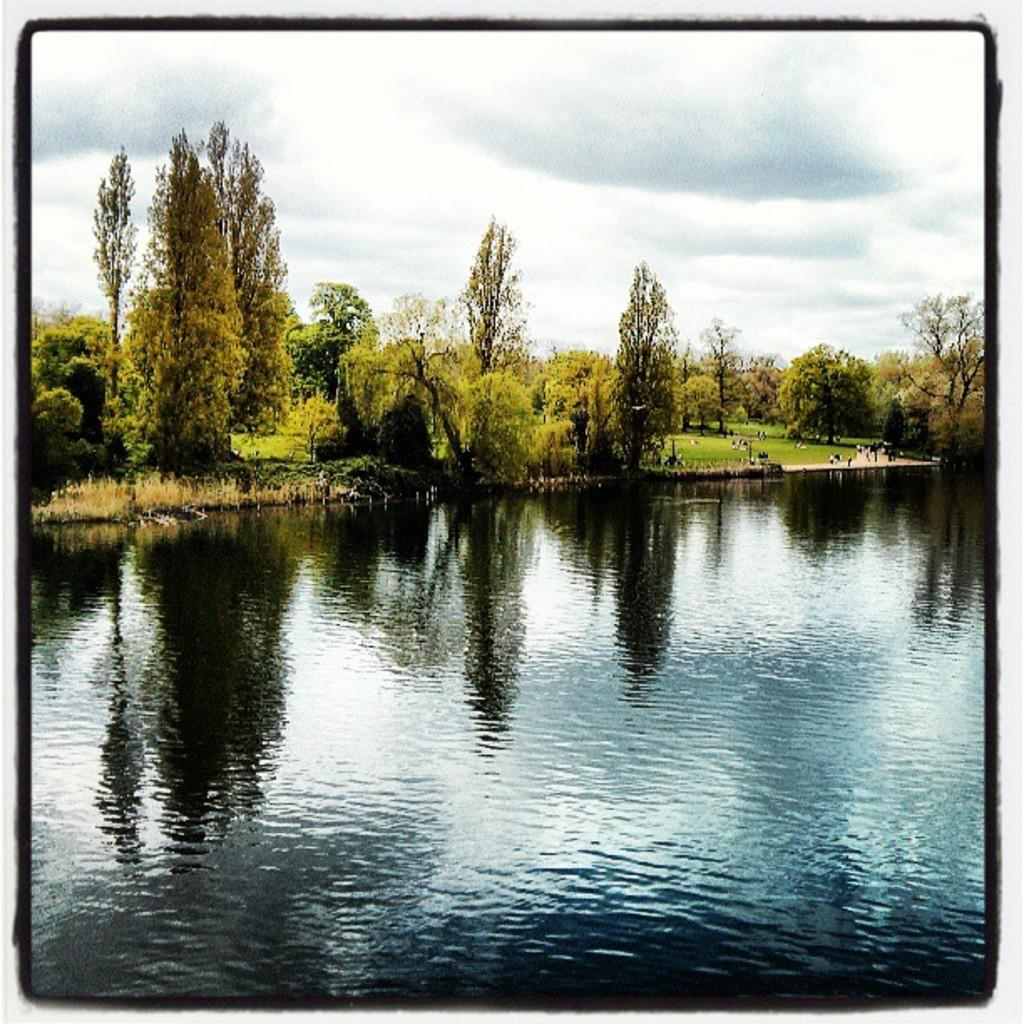What body of water is visible in the image? There is a lake in the image. What type of vegetation is present behind the lake? Trees are present behind the lake. What part of the natural environment is visible in the image? The sky is visible in the image. What is the condition of the sky in the image? The sky is full of clouds. How many snails can be seen crawling on the window in the image? There is no window present in the image, and therefore no snails can be seen crawling on it. 